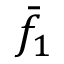Convert formula to latex. <formula><loc_0><loc_0><loc_500><loc_500>{ \bar { f } } _ { 1 }</formula> 